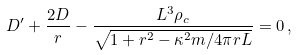Convert formula to latex. <formula><loc_0><loc_0><loc_500><loc_500>D ^ { \prime } + \frac { 2 D } { r } - \frac { L ^ { 3 } \rho _ { c } } { \sqrt { 1 + r ^ { 2 } - { \kappa ^ { 2 } m } / { 4 \pi r L } } } = 0 \, ,</formula> 